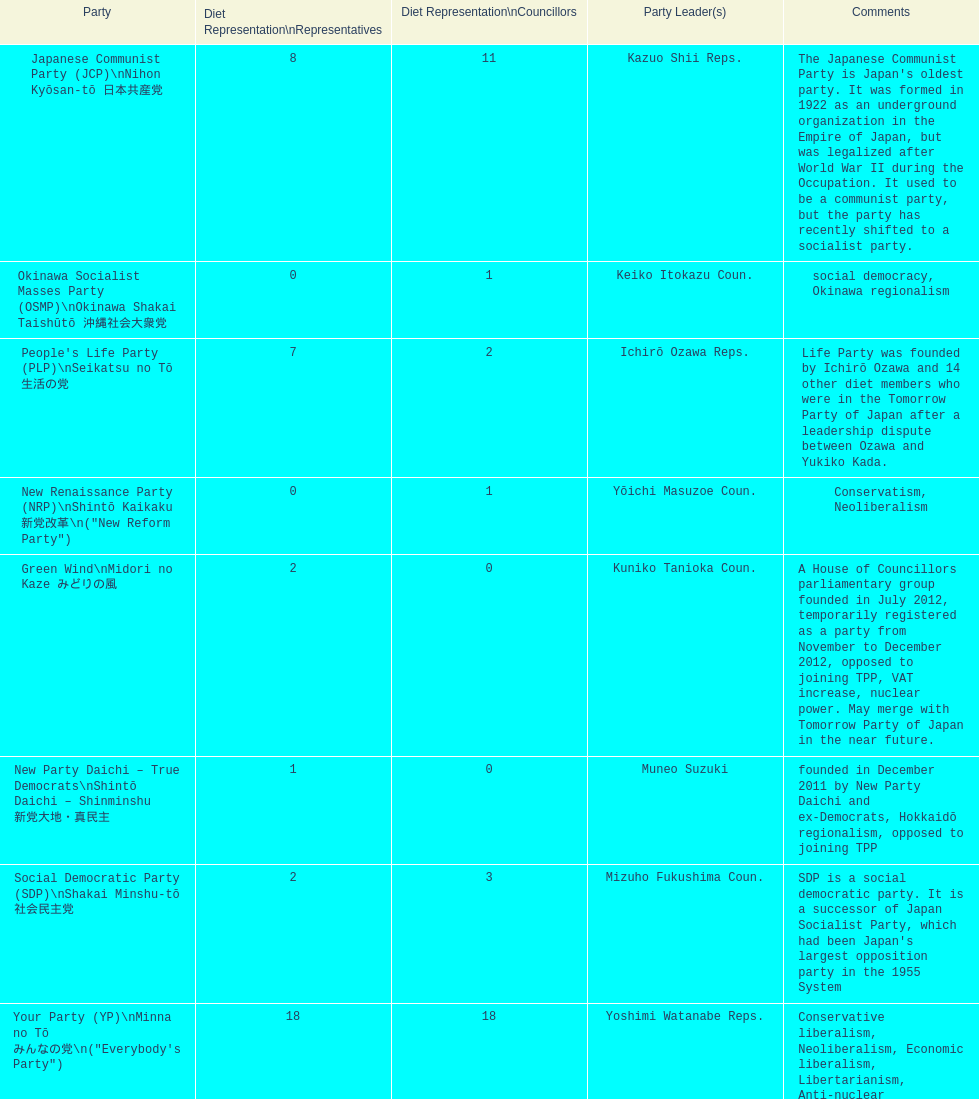What party has the most representatives in the diet representation? Your Party. 